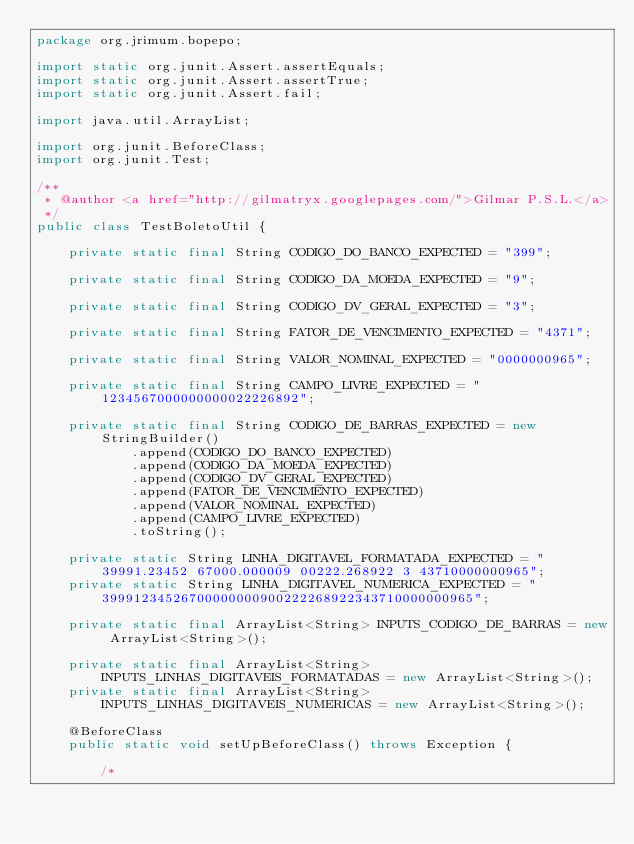Convert code to text. <code><loc_0><loc_0><loc_500><loc_500><_Java_>package org.jrimum.bopepo;

import static org.junit.Assert.assertEquals;
import static org.junit.Assert.assertTrue;
import static org.junit.Assert.fail;

import java.util.ArrayList;

import org.junit.BeforeClass;
import org.junit.Test;

/**
 * @author <a href="http://gilmatryx.googlepages.com/">Gilmar P.S.L.</a>
 */
public class TestBoletoUtil {

	private static final String CODIGO_DO_BANCO_EXPECTED = "399";
	
	private static final String CODIGO_DA_MOEDA_EXPECTED = "9";

	private static final String CODIGO_DV_GERAL_EXPECTED = "3";

	private static final String FATOR_DE_VENCIMENTO_EXPECTED = "4371";
	
	private static final String VALOR_NOMINAL_EXPECTED = "0000000965";
	
	private static final String CAMPO_LIVRE_EXPECTED = "1234567000000000022226892";

	private static final String CODIGO_DE_BARRAS_EXPECTED = new StringBuilder()
			.append(CODIGO_DO_BANCO_EXPECTED)
			.append(CODIGO_DA_MOEDA_EXPECTED)
			.append(CODIGO_DV_GERAL_EXPECTED)
			.append(FATOR_DE_VENCIMENTO_EXPECTED)
			.append(VALOR_NOMINAL_EXPECTED)
			.append(CAMPO_LIVRE_EXPECTED)
			.toString();

	private static String LINHA_DIGITAVEL_FORMATADA_EXPECTED = "39991.23452 67000.000009 00222.268922 3 43710000000965";
	private static String LINHA_DIGITAVEL_NUMERICA_EXPECTED = "39991234526700000000900222268922343710000000965";

	private static final ArrayList<String> INPUTS_CODIGO_DE_BARRAS = new ArrayList<String>();
	
	private static final ArrayList<String> INPUTS_LINHAS_DIGITAVEIS_FORMATADAS = new ArrayList<String>();
	private static final ArrayList<String> INPUTS_LINHAS_DIGITAVEIS_NUMERICAS = new ArrayList<String>();

	@BeforeClass
	public static void setUpBeforeClass() throws Exception {

		/*</code> 